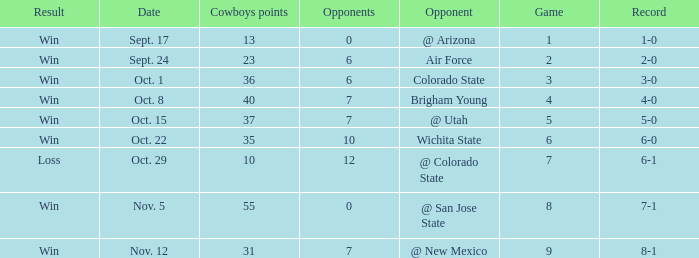When did the Cowboys score 13 points in 1966? Sept. 17. 